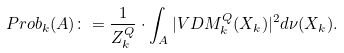Convert formula to latex. <formula><loc_0><loc_0><loc_500><loc_500>P r o b _ { k } ( A ) \colon = \frac { 1 } { Z ^ { Q } _ { k } } \cdot \int _ { A } | V D M _ { k } ^ { Q } ( { X _ { k } } ) | ^ { 2 } d \nu ( { X _ { k } } ) .</formula> 